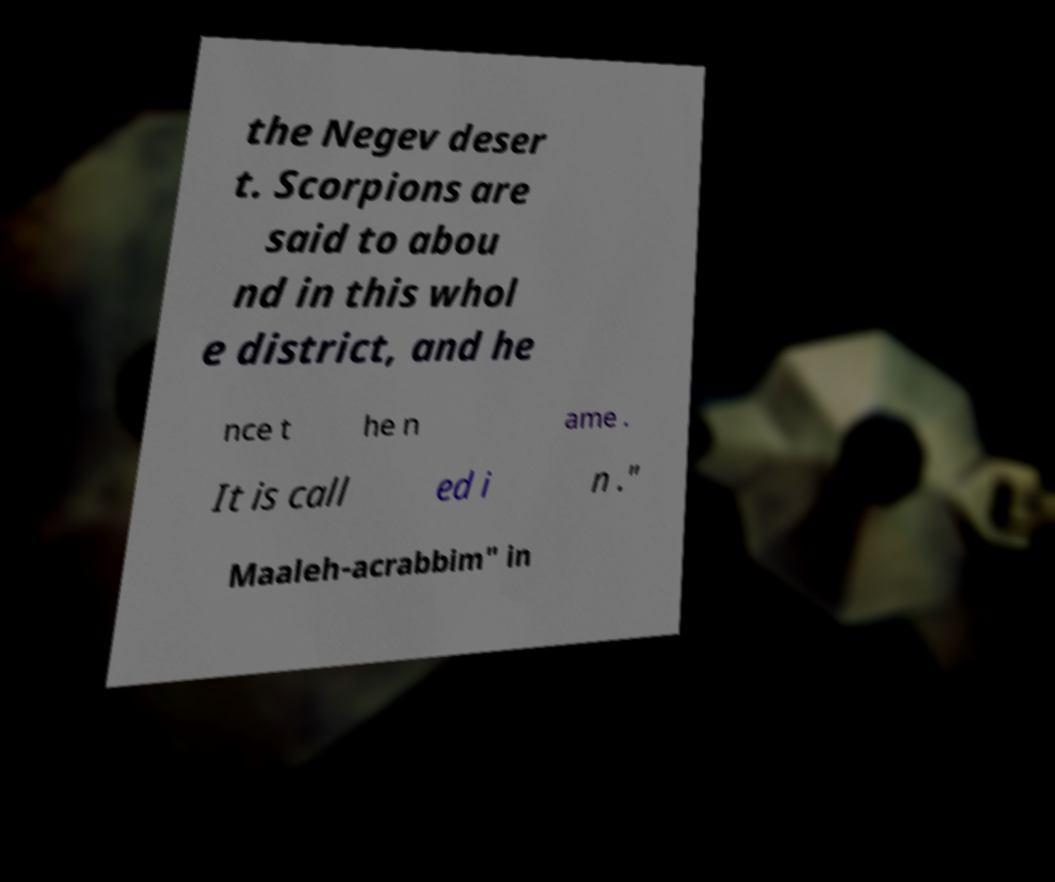What messages or text are displayed in this image? I need them in a readable, typed format. the Negev deser t. Scorpions are said to abou nd in this whol e district, and he nce t he n ame . It is call ed i n ." Maaleh-acrabbim" in 